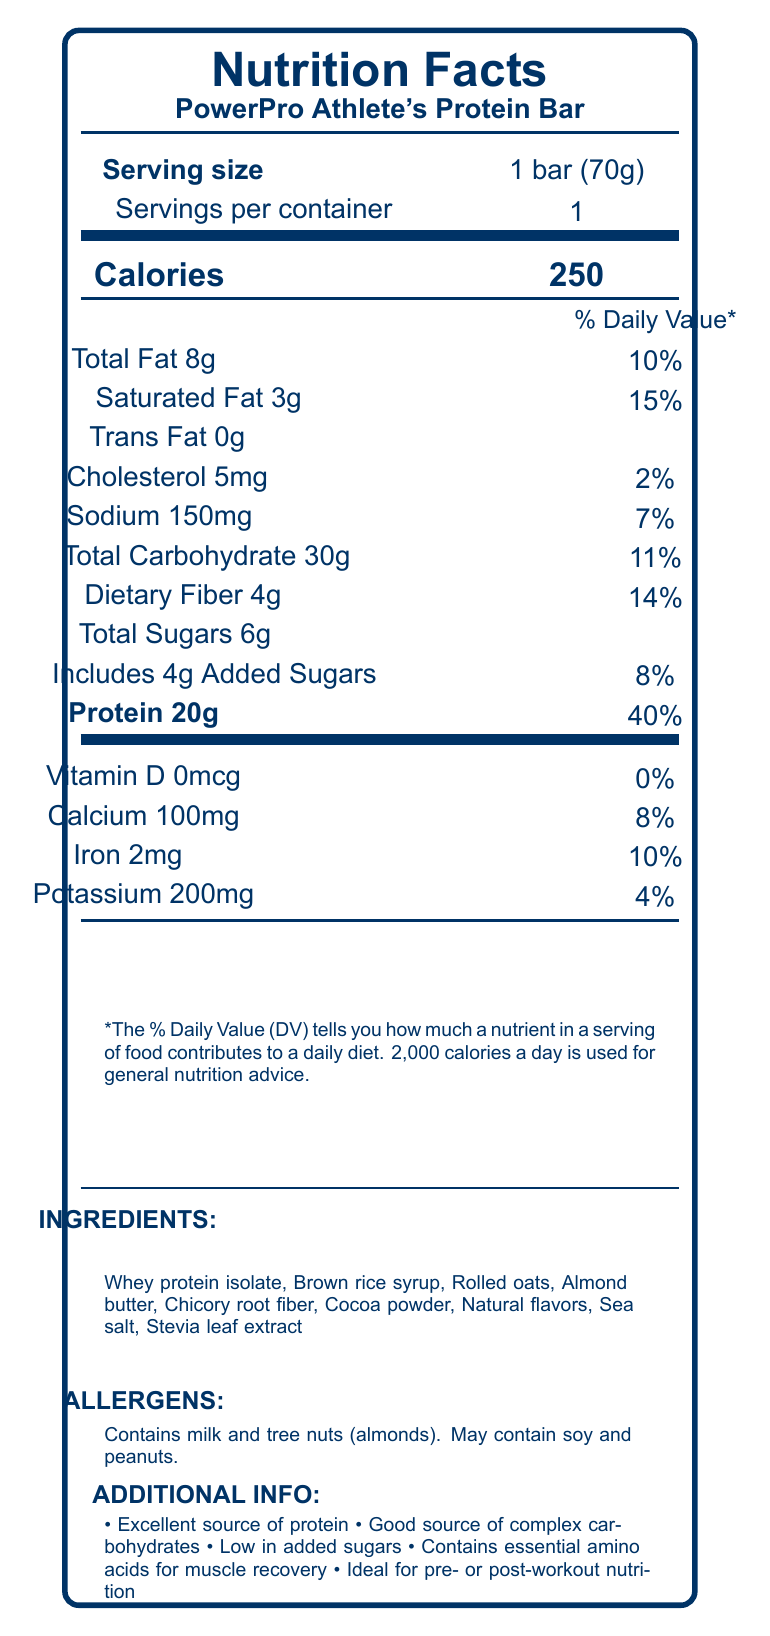what is the serving size of the PowerPro Athlete's Protein Bar? The serving size is listed at the top portion of the document under the product name.
Answer: 1 bar (70g) how much protein does one serving contain? The protein content is highlighted in bold and is mentioned as "Protein 20g".
Answer: 20g what percentage of the daily value of calcium does one bar provide? The daily value percentage for calcium is listed under the vitamins and minerals section as "Calcium 100mg 8%".
Answer: 8% what are the main ingredients of the PowerPro Athlete's Protein Bar? The ingredients are listed at the bottom section of the document under the "INGREDIENTS" heading.
Answer: Whey protein isolate, Brown rice syrup, Rolled oats, Almond butter, Chicory root fiber, Cocoa powder, Natural flavors, Sea salt, Stevia leaf extract how many grams of dietary fiber are in each bar? The dietary fiber content is listed under the carbohydrate section as "Dietary Fiber 4g".
Answer: 4g what best describes the primary audience for this protein bar? A. Children B. Athletes C. Elderly D. General public The title "PowerPro Athlete's Protein Bar" and additional info such as "Ideal for pre- or post-workout nutrition" indicate it is marketed towards athletes.
Answer: B how many total carbohydrates are in each serving? A. 20g B. 25g C. 30g D. 35g The total carbohydrate content is listed as "Total Carbohydrate 30g".
Answer: C does this bar contain any trans fat? It is explicitly mentioned under the fats section as "Trans Fat 0g".
Answer: No is the product low in added sugars? The additional information states "Low in added sugars" and the label mentions 4g of added sugars which is 8% of the daily value.
Answer: Yes summarize the primary nutritional benefits of this protein bar. The document highlights the high protein content, presence of complex carbohydrates, low added sugars, and essential amino acids, emphasizing its use for pre- or post-workout.
Answer: The PowerPro Athlete's Protein Bar is high in protein (20g) and complex carbohydrates (30g), low in added sugars (4g), and contains dietary fiber (4g). It also provides essential amino acids for muscle recovery, making it ideal for athletes for pre- or post-workout nutrition. what is the potassium content per serving? The potassium content is listed under the vitamins and minerals section as "Potassium 200mg".
Answer: 200mg can this bar be safely consumed by someone with a peanut allergy? The allergens section states "May contain soy and peanuts," indicating potential cross-contamination which could be unsafe for someone with a peanut allergy.
Answer: Not necessarily why might understanding carbohydrate chemistry and modification be relevant for this product? The document does not provide detailed reasons for the relevance of carbohydrate chemistry and modification to the product.
Answer: Not enough information how many servings are there per container? This is listed near the serving size section as "Servings per container 1".
Answer: 1 what nutritional information contributes 11% of the Daily Value (DV)? A. Total Fat B. Sodium C. Total Carbohydrate D. Protein The total carbohydrate contributions are listed as "Total Carbohydrate 30g 11%".
Answer: C which allergen is not present in the ingredients but may be present in the product? The allergens section mentions "May contain soy and peanuts," indicating potential cross-contamination while soy is not listed as an ingredient.
Answer: Soy what is the saturated fat content and its daily value percentage? The document lists "Saturated Fat 3g" and its daily value as "15%".
Answer: Saturated Fat 3g (15%) 